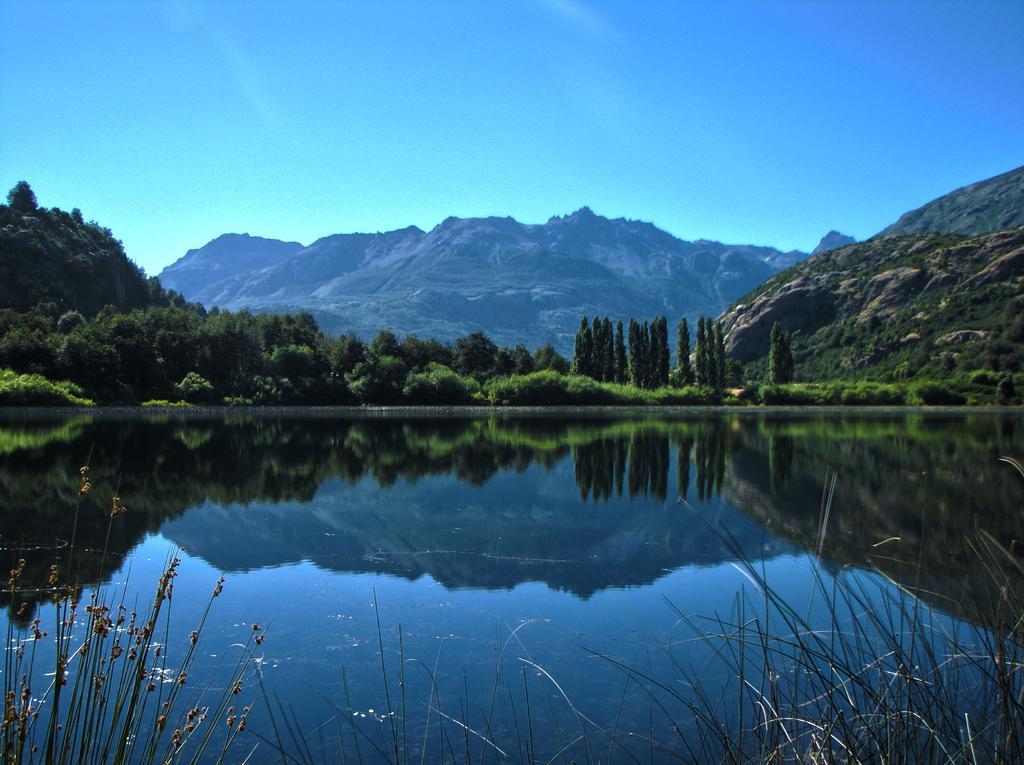Could you give a brief overview of what you see in this image? In this image I can see water, number of trees, mountains and the sky in background. I can also see reflection here on water. 